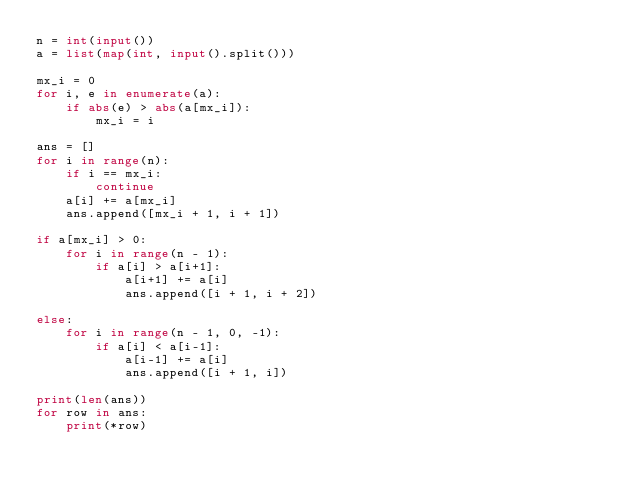<code> <loc_0><loc_0><loc_500><loc_500><_Python_>n = int(input())
a = list(map(int, input().split()))

mx_i = 0
for i, e in enumerate(a):
    if abs(e) > abs(a[mx_i]):
        mx_i = i

ans = []
for i in range(n):
    if i == mx_i:
        continue
    a[i] += a[mx_i]
    ans.append([mx_i + 1, i + 1])

if a[mx_i] > 0:
    for i in range(n - 1):
        if a[i] > a[i+1]:
            a[i+1] += a[i]
            ans.append([i + 1, i + 2])

else:
    for i in range(n - 1, 0, -1):
        if a[i] < a[i-1]:
            a[i-1] += a[i]
            ans.append([i + 1, i])

print(len(ans))
for row in ans:
    print(*row)
</code> 